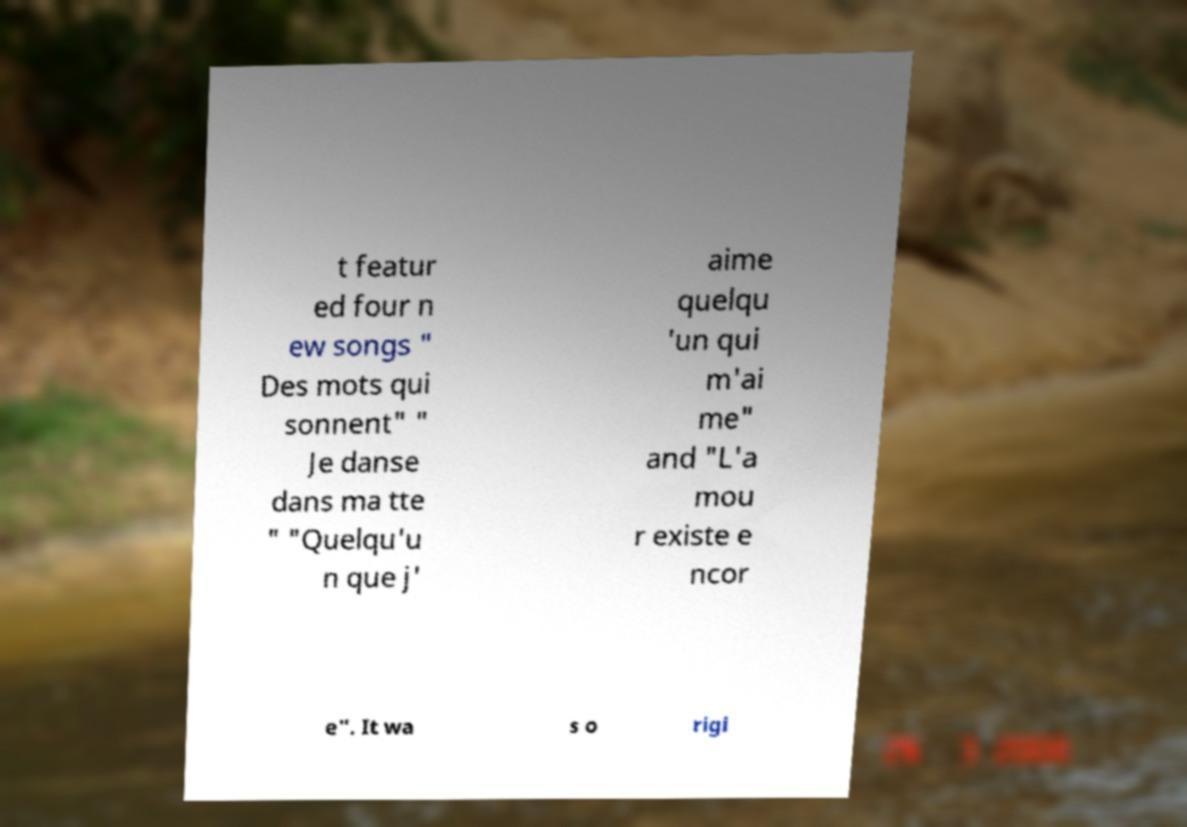I need the written content from this picture converted into text. Can you do that? t featur ed four n ew songs " Des mots qui sonnent" " Je danse dans ma tte " "Quelqu'u n que j' aime quelqu 'un qui m'ai me" and "L'a mou r existe e ncor e". It wa s o rigi 